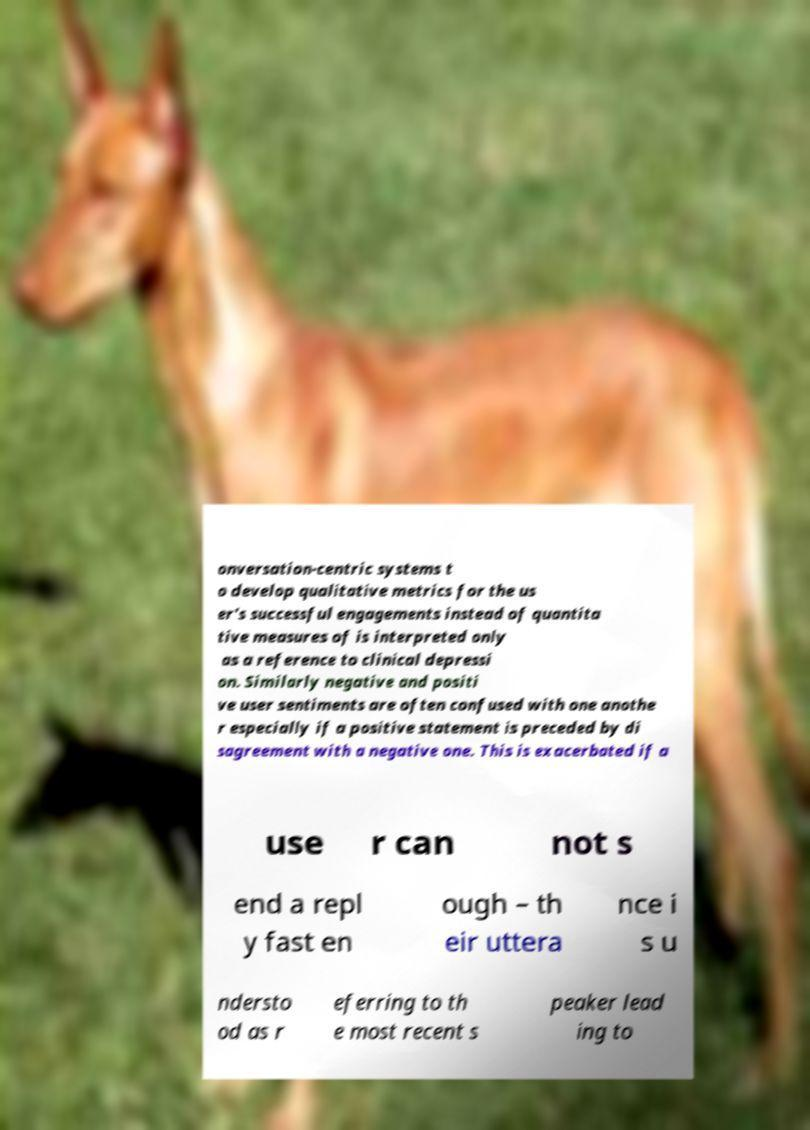There's text embedded in this image that I need extracted. Can you transcribe it verbatim? onversation-centric systems t o develop qualitative metrics for the us er's successful engagements instead of quantita tive measures of is interpreted only as a reference to clinical depressi on. Similarly negative and positi ve user sentiments are often confused with one anothe r especially if a positive statement is preceded by di sagreement with a negative one. This is exacerbated if a use r can not s end a repl y fast en ough – th eir uttera nce i s u ndersto od as r eferring to th e most recent s peaker lead ing to 